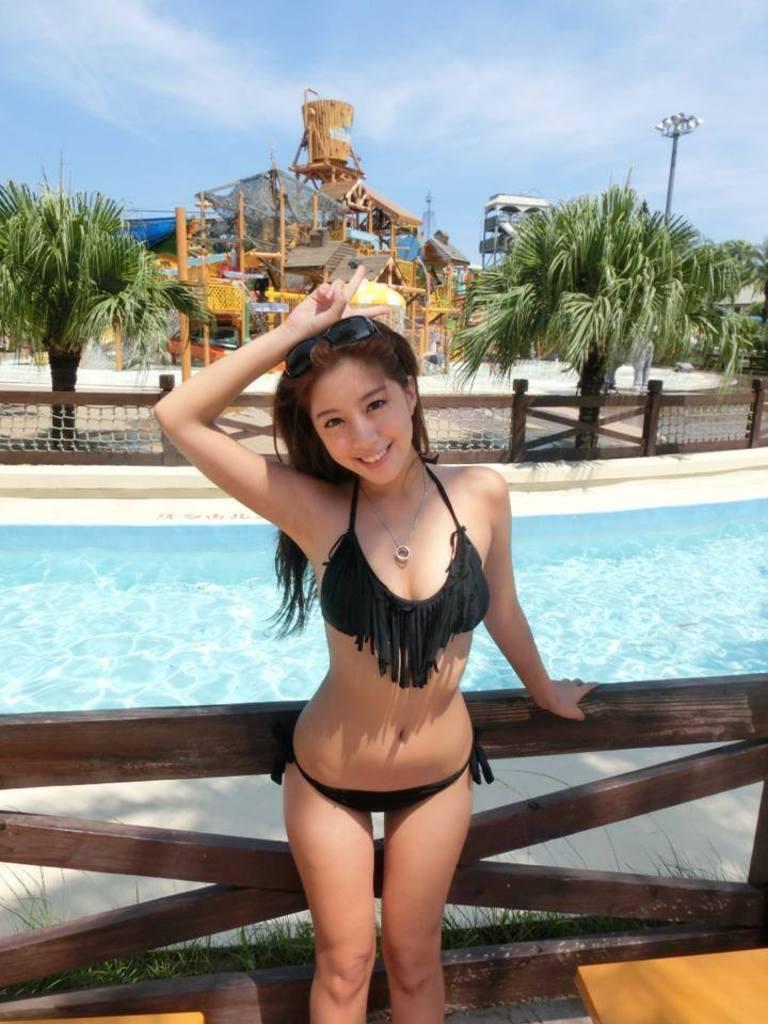Describe this image in one or two sentences. In this image there is a girl standing in front of the wooden fence. In the background there is a swimming pool. At the top there is the sky. There are two trees on either side of the image. In the middle it looks like a building. 